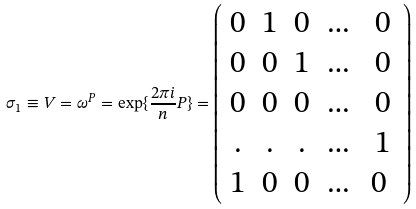<formula> <loc_0><loc_0><loc_500><loc_500>\sigma _ { 1 } \equiv V = \omega ^ { P } = \exp \{ \frac { 2 \pi i } { n } P \} = \left ( \begin{array} { c c c c c } 0 & 1 & 0 & \dots & 0 \\ 0 & 0 & 1 & \dots & 0 \\ 0 & 0 & 0 & \dots & 0 \\ . & . & . & \dots & 1 \\ 1 & 0 & 0 & \dots & 0 \ \end{array} \right )</formula> 